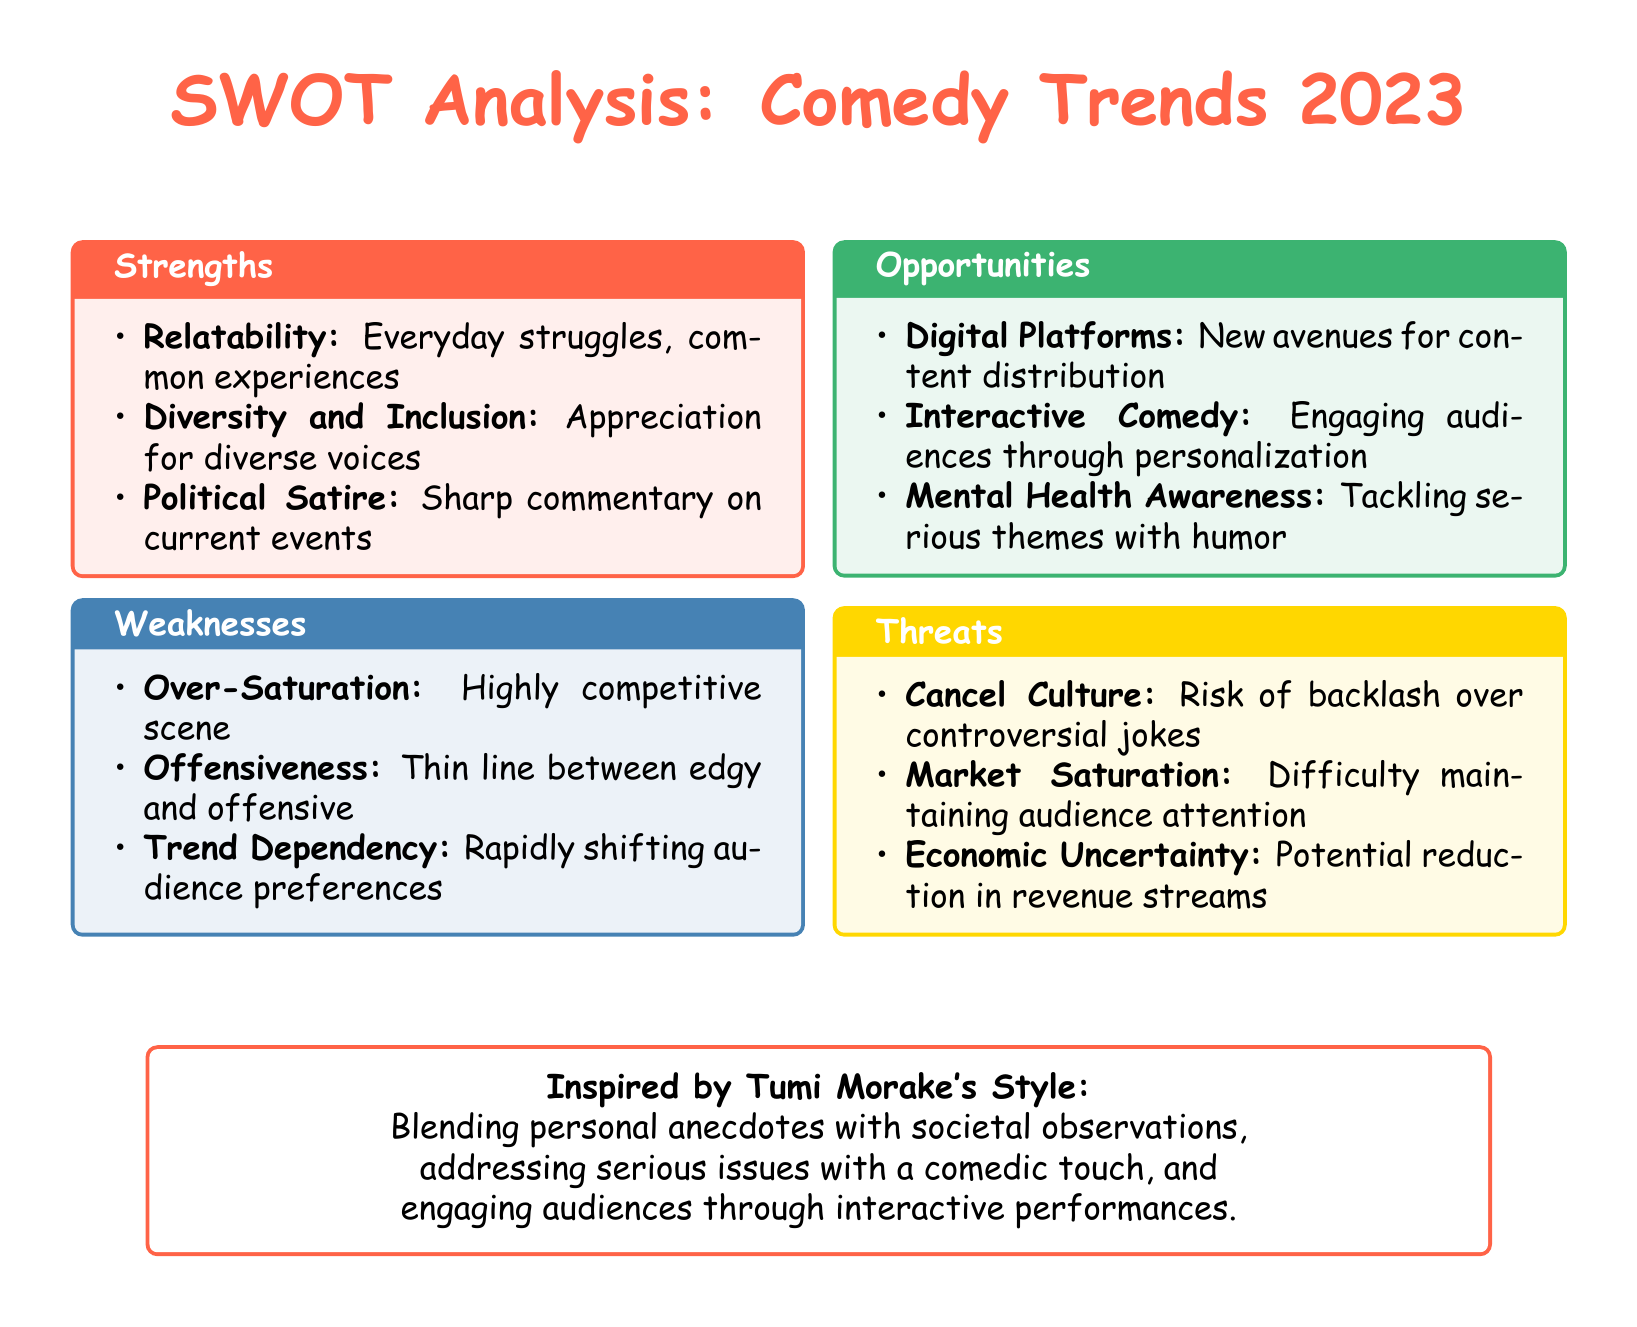What is the title of the analysis? The title is presented clearly at the beginning of the document, which is "SWOT Analysis: Comedy Trends 2023."
Answer: SWOT Analysis: Comedy Trends 2023 What is one strength mentioned in the document? The document lists multiple strengths in the SWOT analysis section, such as "Relatability."
Answer: Relatability What is one weakness listed in the analysis? The weaknesses are detailed in the respective section, with "Over-Saturation" being one of them.
Answer: Over-Saturation What opportunity is highlighted for comedians in 2023? The document mentions several opportunities, including "Digital Platforms."
Answer: Digital Platforms What threat relates to comedians facing backlash? One of the threats listed in the document is "Cancel Culture," which directly addresses the potential for backlash.
Answer: Cancel Culture How does Tumi Morake's style influence comedy? The document provides insights into how Morake's style is characterized by blending personal anecdotes with societal observations.
Answer: Blending personal anecdotes with societal observations Which color is used for the strengths section? The strengths section is visually represented using a specific color, which is "comedyred."
Answer: comedyred What is the primary theme of the opportunities identified in the SWOT analysis? The opportunities mainly focus on engaging audiences through new methods, like "Interactive Comedy."
Answer: Interactive Comedy 